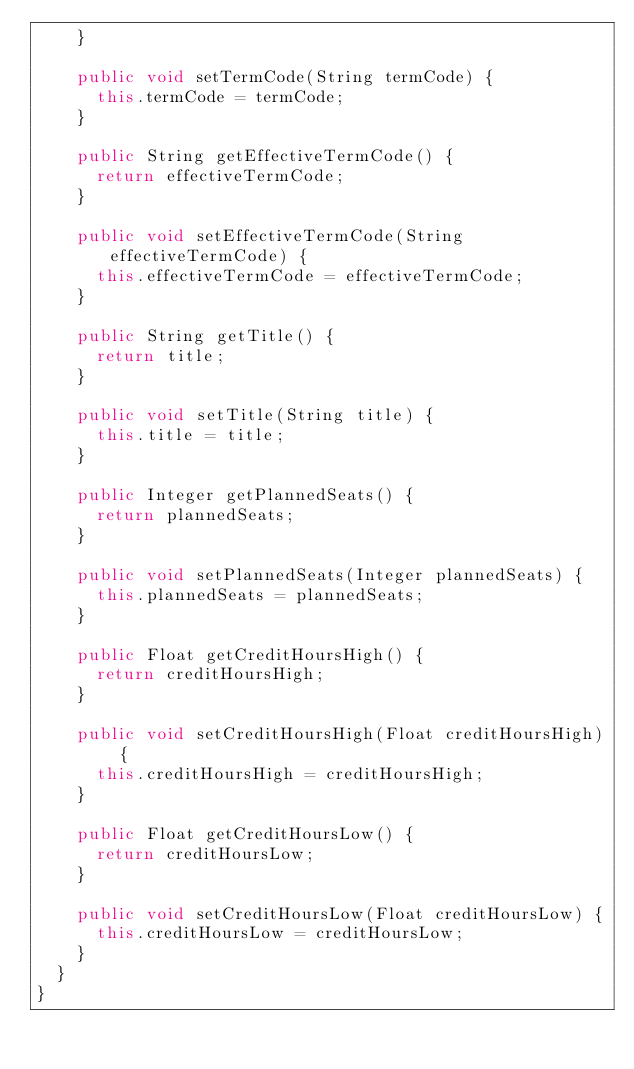Convert code to text. <code><loc_0><loc_0><loc_500><loc_500><_Java_>		}

		public void setTermCode(String termCode) {
			this.termCode = termCode;
		}

		public String getEffectiveTermCode() {
			return effectiveTermCode;
		}

		public void setEffectiveTermCode(String effectiveTermCode) {
			this.effectiveTermCode = effectiveTermCode;
		}

		public String getTitle() {
			return title;
		}

		public void setTitle(String title) {
			this.title = title;
		}

		public Integer getPlannedSeats() {
			return plannedSeats;
		}

		public void setPlannedSeats(Integer plannedSeats) {
			this.plannedSeats = plannedSeats;
		}

		public Float getCreditHoursHigh() {
			return creditHoursHigh;
		}

		public void setCreditHoursHigh(Float creditHoursHigh) {
			this.creditHoursHigh = creditHoursHigh;
		}

		public Float getCreditHoursLow() {
			return creditHoursLow;
		}

		public void setCreditHoursLow(Float creditHoursLow) {
			this.creditHoursLow = creditHoursLow;
		}
	}
}
</code> 